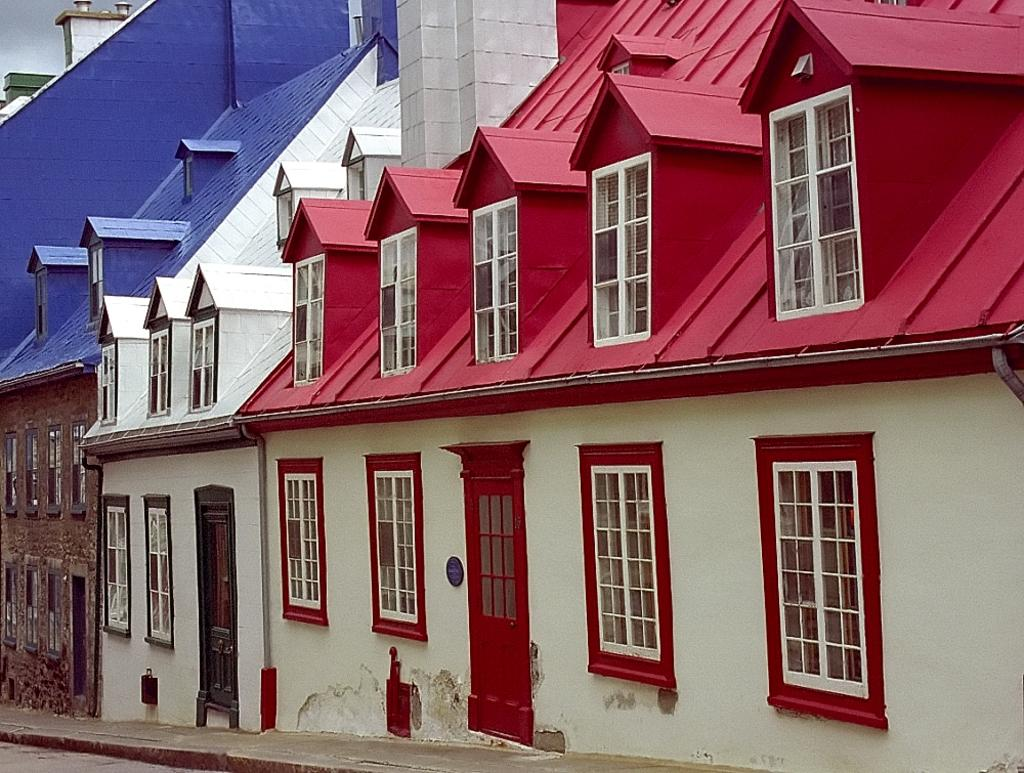What type of structures can be seen in the image? There are many buildings in the image. What features are visible on the buildings? Windows and doors are visible in the image. What is visible in the top left corner of the image? The sky and clouds are present in the top left corner of the image. What type of frame is the writer using to write in the image? There is no writer or frame present in the image; it features buildings, windows, doors, and a sky with clouds. 